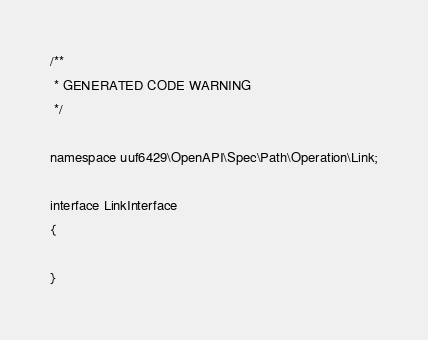<code> <loc_0><loc_0><loc_500><loc_500><_PHP_>/**
 * GENERATED CODE WARNING
 */

namespace uuf6429\OpenAPI\Spec\Path\Operation\Link;

interface LinkInterface
{

}
</code> 